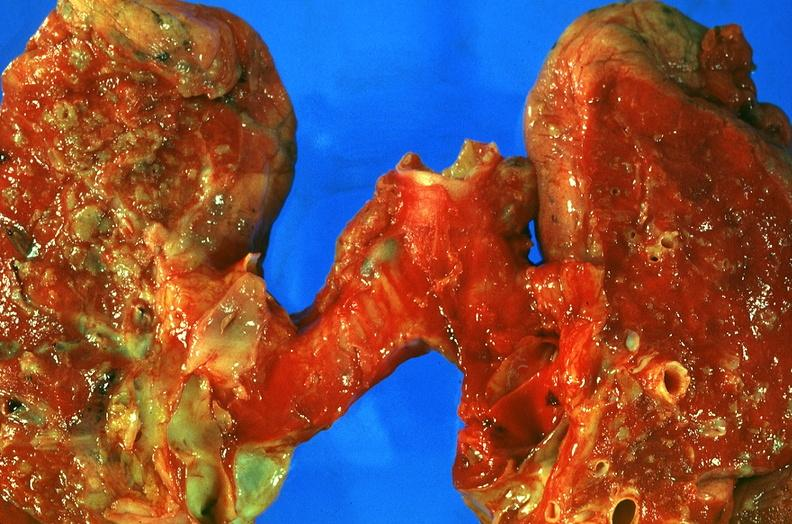what is present?
Answer the question using a single word or phrase. Respiratory 